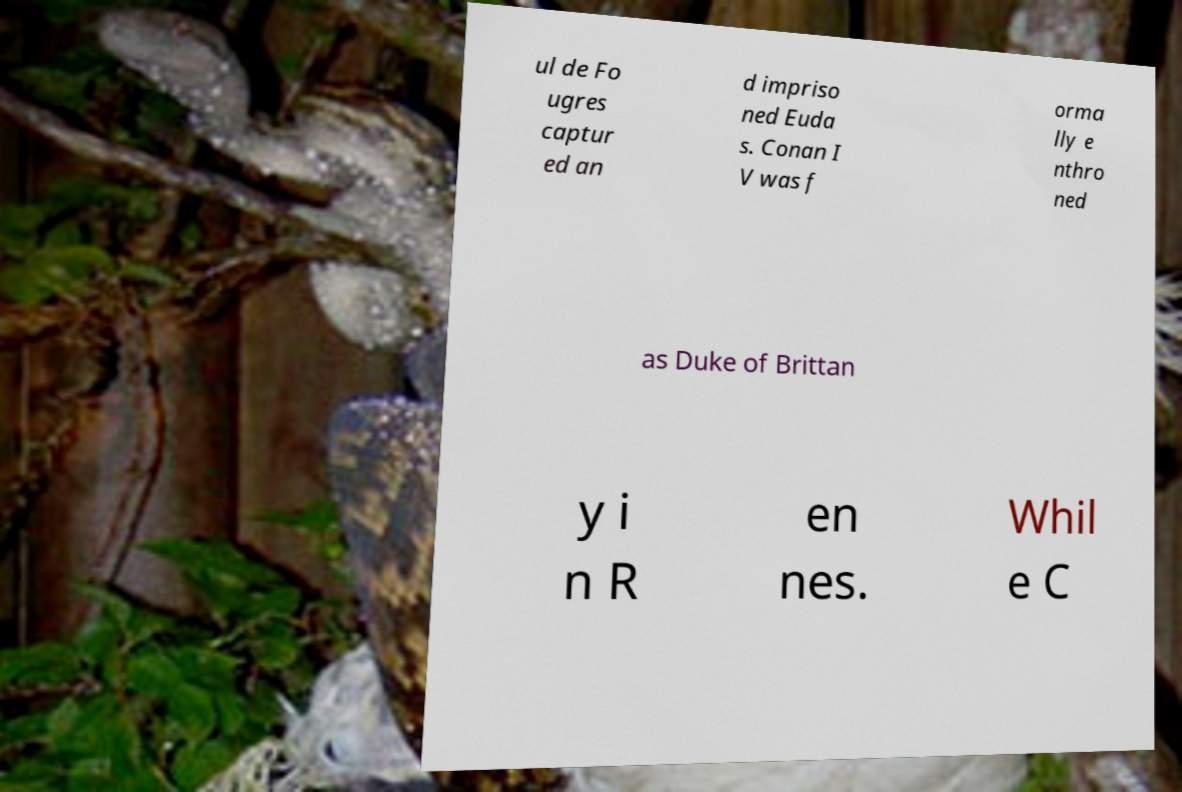There's text embedded in this image that I need extracted. Can you transcribe it verbatim? ul de Fo ugres captur ed an d impriso ned Euda s. Conan I V was f orma lly e nthro ned as Duke of Brittan y i n R en nes. Whil e C 